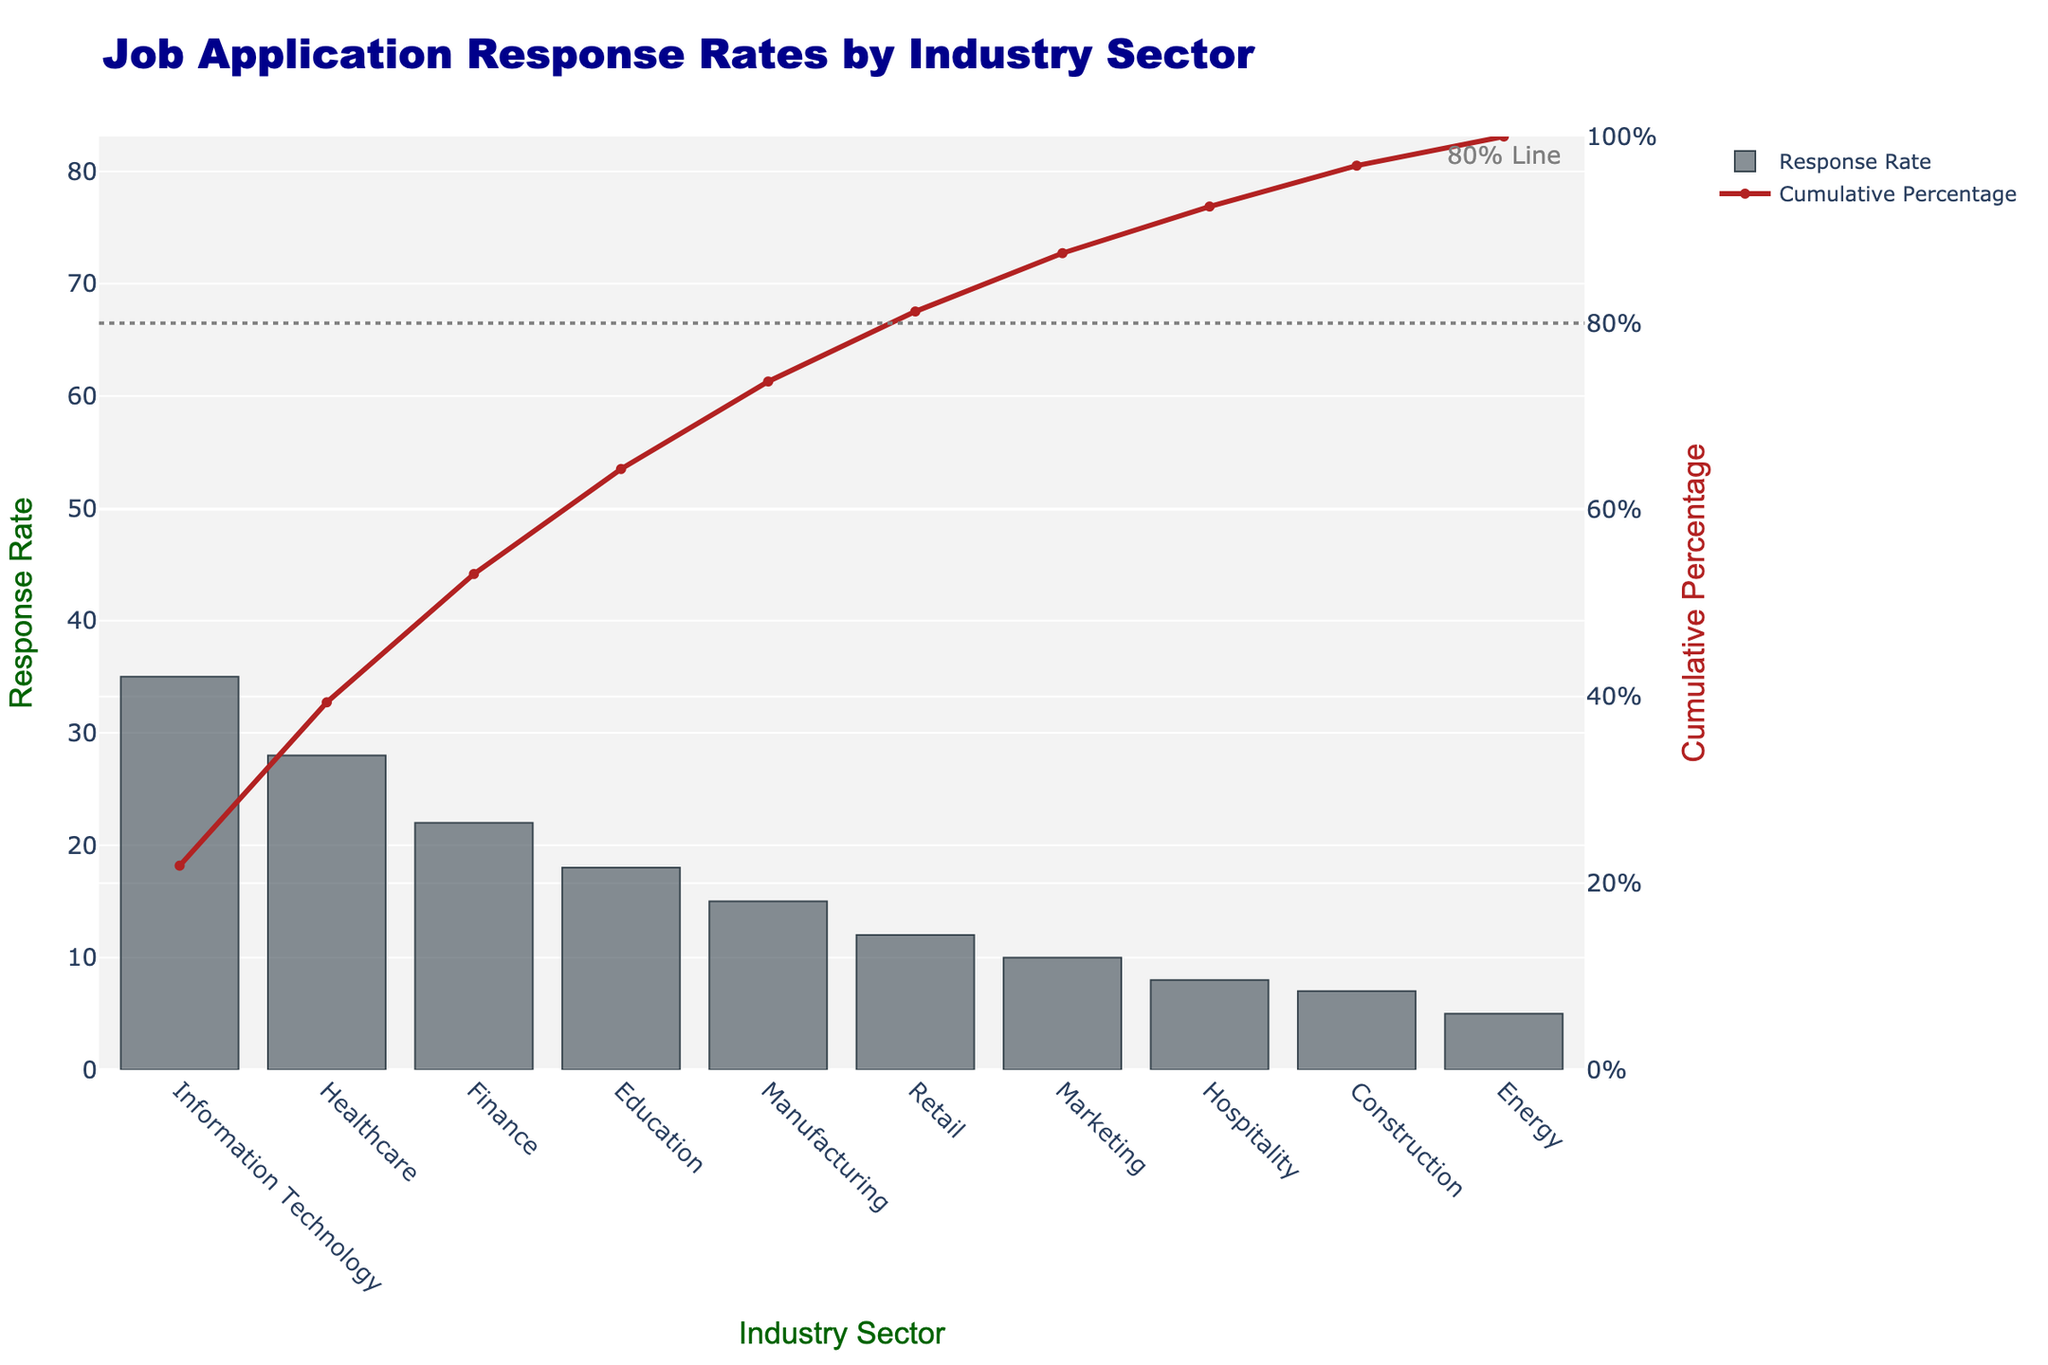What's the title of the chart? The title is displayed at the top of the chart in larger and bold font.
Answer: Job Application Response Rates by Industry Sector How many industry sectors are represented in the chart? The chart shows separate bars for each industry sector along the x-axis.
Answer: 10 Which industry sector has the highest response rate? The heights of the bars indicate the response rates. The highest bar will correspond to the highest response rate.
Answer: Information Technology What is the response rate for the Healthcare industry? Locate the bar labeled "Healthcare" on the x-axis and read the corresponding value on the y-axis.
Answer: 28 What's the cumulative percentage after the top three industry sectors? Sum the response rates for the top three sectors (35% for IT, 28% for Healthcare, and 22% for Finance), then compute their cumulative percentage of the total (35 + 28 + 22) / 160 * 100%.
Answer: 53.125% How does the response rate for the Retail sector compare to the Manufacturing sector? Locate both the "Retail" and "Manufacturing" bars and compare their heights, or read their respective values on the y-axis.
Answer: Retail (12) is less than Manufacturing (15) Where is the 80% cumulative percentage marker placed in the chart? The chart includes a horizontal dotted line and an annotation at the y-axis 80%, indicating where the cumulative percentage reaches 80%.
Answer: Near the end of the Education sector bar Which sector reaches the cumulative percentage closest to 50%? Observe the cumulative percentage line and identify the sector where the y-axis value of the line crosses closest to 50%.
Answer: Finance What is the color of the bars representing response rates? The visual appearance of the bars in the chart reveals their color.
Answer: Dark grey (described as "rgba(58, 71, 80, 0.6)") Is the response rate for the Energy sector above or below 10%? Locate the "Energy" sector bar and read its value on the y-axis.
Answer: Below (5%) 